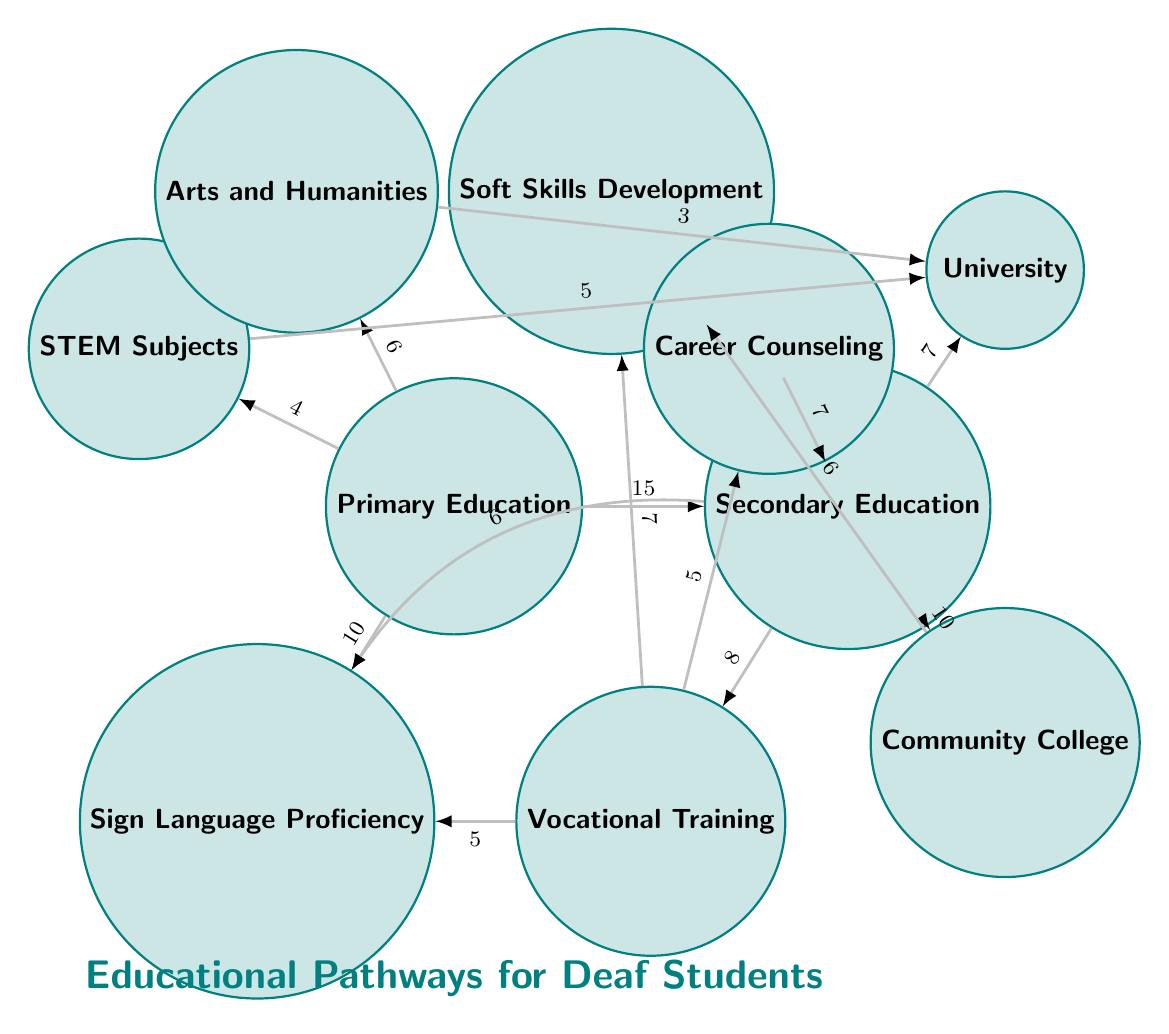What is the total number of nodes in the diagram? The diagram contains ten distinct nodes: Primary Education, Secondary Education, Vocational Training, Sign Language Proficiency, STEM Subjects, Arts and Humanities, Soft Skills Development, Career Counseling, Community College, and University. Therefore, the total number is counted simply by listing each node.
Answer: 10 What is the value of the link between Secondary Education and University? The link between Secondary Education and University has a value of 7, which is indicated on the edge connecting these two nodes.
Answer: 7 Which educational level has the highest link value in the diagram? The link from Primary Education to Secondary Education has the highest value of 15. This can be confirmed by checking all the links and their values.
Answer: Primary Education How many subjects are correlated with Primary Education? Primary Education directly links to Sign Language Proficiency, STEM Subjects, and Arts and Humanities, which totals three subjects. This is calculated by counting each distinct target node connected to Primary Education.
Answer: 3 What is the sum of link values from Secondary Education to Vocational Training and Community College? The link from Secondary Education to Vocational Training has a value of 8, and the link to Community College has a value of 10. The total sum is calculated by adding these two values together: 8 + 10 = 18.
Answer: 18 Which educational pathway is linked to both Soft Skills Development and Career Counseling? Both Soft Skills Development and Career Counseling are linked through Vocational Training and Secondary Education, respectively. This can be identified by checking the edges that connect to these specific nodes.
Answer: Secondary Education What is the total value of links originating from Vocational Training? The links originating from Vocational Training lead to Sign Language Proficiency (5), Soft Skills Development (7), and Career Counseling (5). The total value is calculated by summing these: 5 + 7 + 5 = 17.
Answer: 17 What is the link value between Primary Education and Sign Language Proficiency? The value of the link between Primary Education and Sign Language Proficiency is 10, as indicated on the edge connecting these two nodes.
Answer: 10 Which two subjects have a direct link to the University? The subjects with direct links to the University are STEM Subjects and Arts and Humanities, as shown by the connecting edges leading from these nodes to the University.
Answer: STEM Subjects, Arts and Humanities 